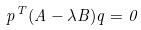Convert formula to latex. <formula><loc_0><loc_0><loc_500><loc_500>p ^ { T } ( A - \lambda B ) q = 0</formula> 